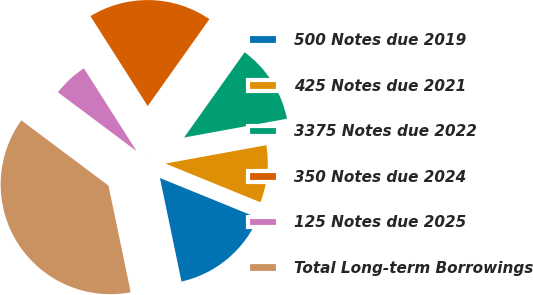Convert chart. <chart><loc_0><loc_0><loc_500><loc_500><pie_chart><fcel>500 Notes due 2019<fcel>425 Notes due 2021<fcel>3375 Notes due 2022<fcel>350 Notes due 2024<fcel>125 Notes due 2025<fcel>Total Long-term Borrowings<nl><fcel>15.58%<fcel>9.03%<fcel>12.3%<fcel>18.85%<fcel>5.75%<fcel>38.49%<nl></chart> 